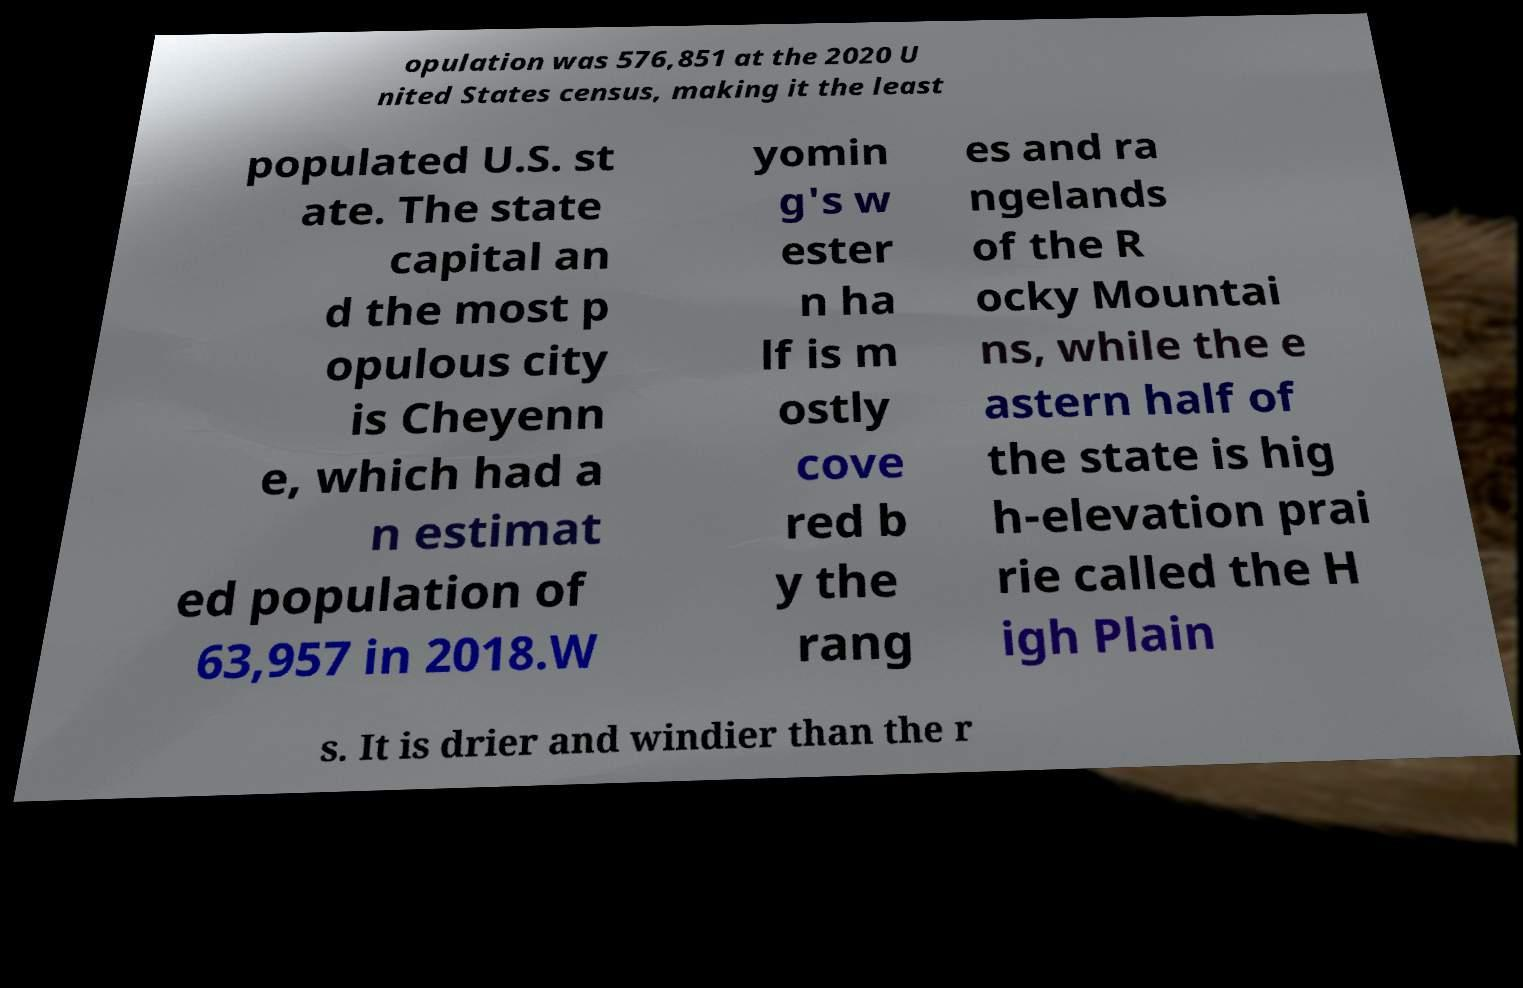For documentation purposes, I need the text within this image transcribed. Could you provide that? opulation was 576,851 at the 2020 U nited States census, making it the least populated U.S. st ate. The state capital an d the most p opulous city is Cheyenn e, which had a n estimat ed population of 63,957 in 2018.W yomin g's w ester n ha lf is m ostly cove red b y the rang es and ra ngelands of the R ocky Mountai ns, while the e astern half of the state is hig h-elevation prai rie called the H igh Plain s. It is drier and windier than the r 